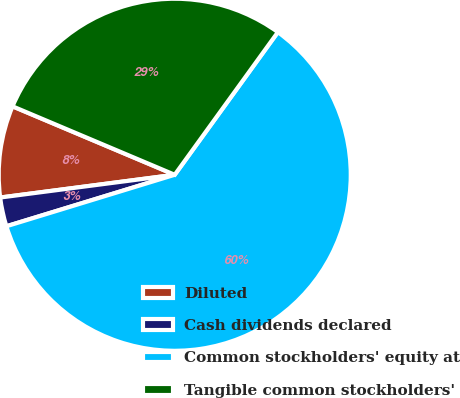Convert chart. <chart><loc_0><loc_0><loc_500><loc_500><pie_chart><fcel>Diluted<fcel>Cash dividends declared<fcel>Common stockholders' equity at<fcel>Tangible common stockholders'<nl><fcel>8.42%<fcel>2.66%<fcel>60.31%<fcel>28.61%<nl></chart> 